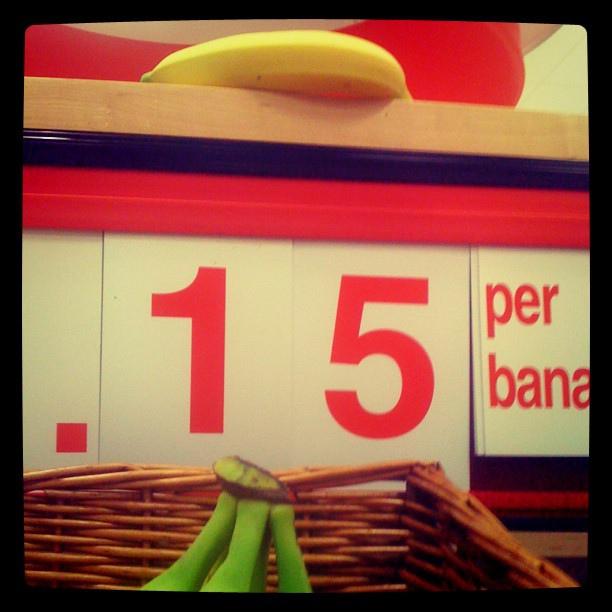What organization sponsored this ad?
Quick response, please. Target. What type of doctor would use this card?
Be succinct. None. What is the price on the sign?
Write a very short answer. .15. What color is the banana in the basket?
Keep it brief. Green. Is the price for bananas shown?
Write a very short answer. Yes. What is the number?
Be succinct. 15. 